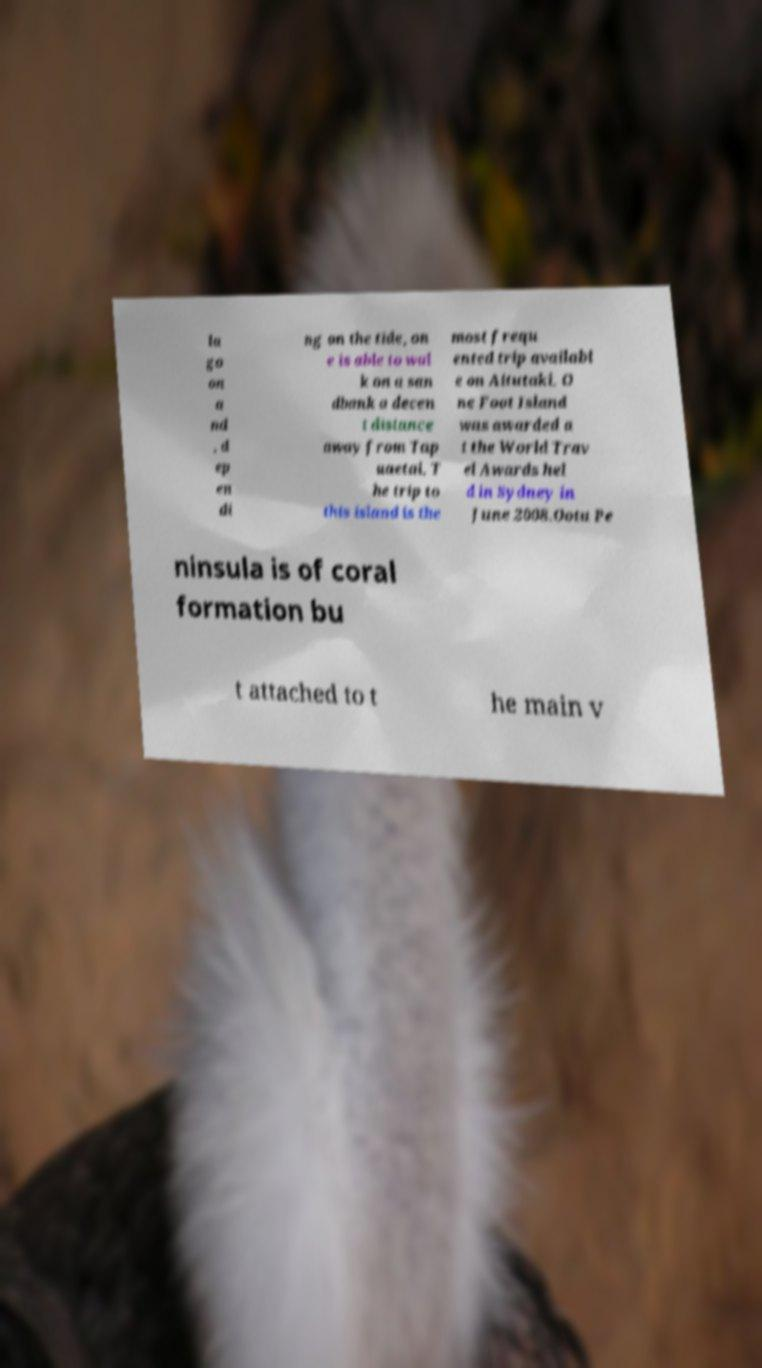What messages or text are displayed in this image? I need them in a readable, typed format. la go on a nd , d ep en di ng on the tide, on e is able to wal k on a san dbank a decen t distance away from Tap uaetai. T he trip to this island is the most frequ ented trip availabl e on Aitutaki. O ne Foot Island was awarded a t the World Trav el Awards hel d in Sydney in June 2008.Ootu Pe ninsula is of coral formation bu t attached to t he main v 